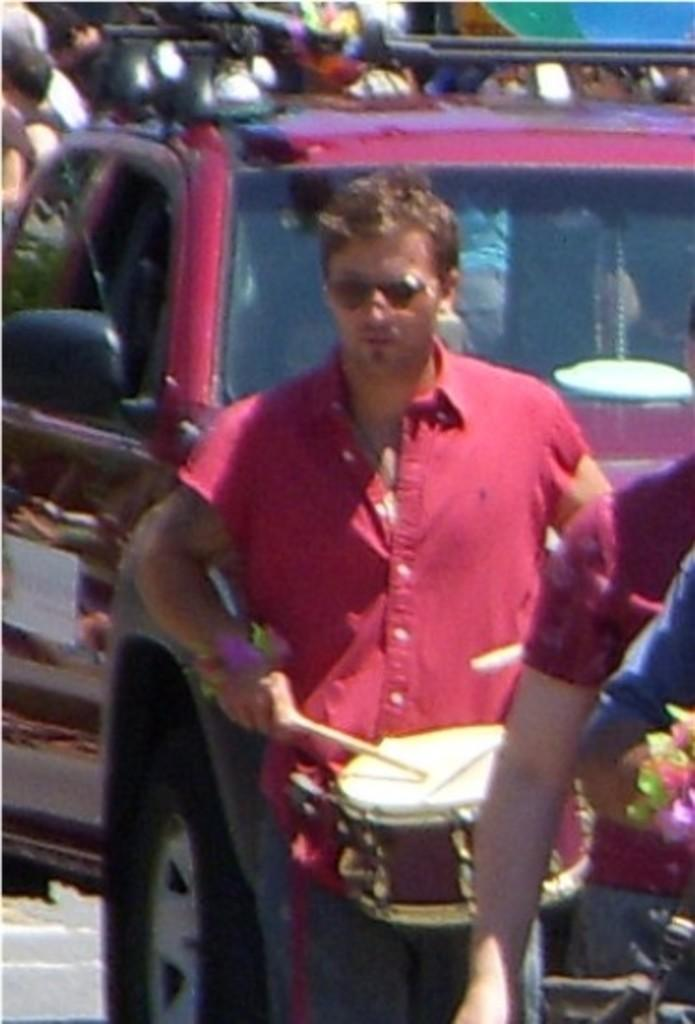What is the person in the image doing? The person in the image is playing a musical instrument. What can be seen behind the person? A: There is a vehicle visible behind the person. Are there any other people in the image? Yes, there are people in the background of the image. What type of card is being used to play the musical instrument in the image? There is no card present in the image; the person is playing a musical instrument with their hands. 